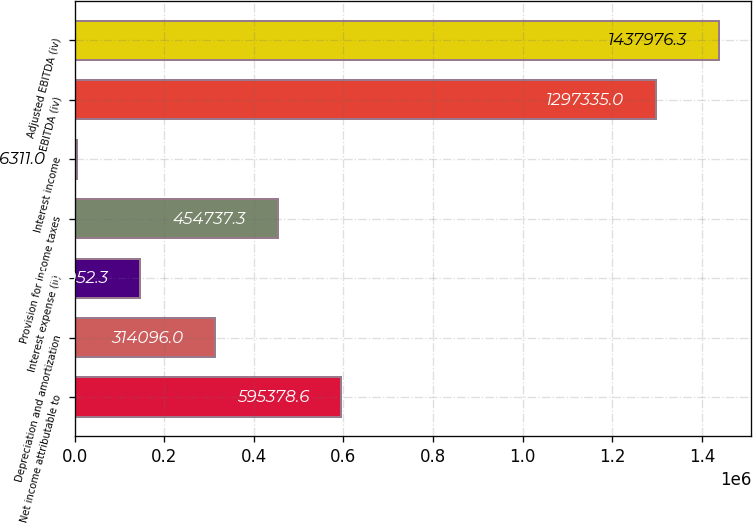Convert chart to OTSL. <chart><loc_0><loc_0><loc_500><loc_500><bar_chart><fcel>Net income attributable to<fcel>Depreciation and amortization<fcel>Interest expense (ii)<fcel>Provision for income taxes<fcel>Interest income<fcel>EBITDA (iv)<fcel>Adjusted EBITDA (iv)<nl><fcel>595379<fcel>314096<fcel>146952<fcel>454737<fcel>6311<fcel>1.29734e+06<fcel>1.43798e+06<nl></chart> 